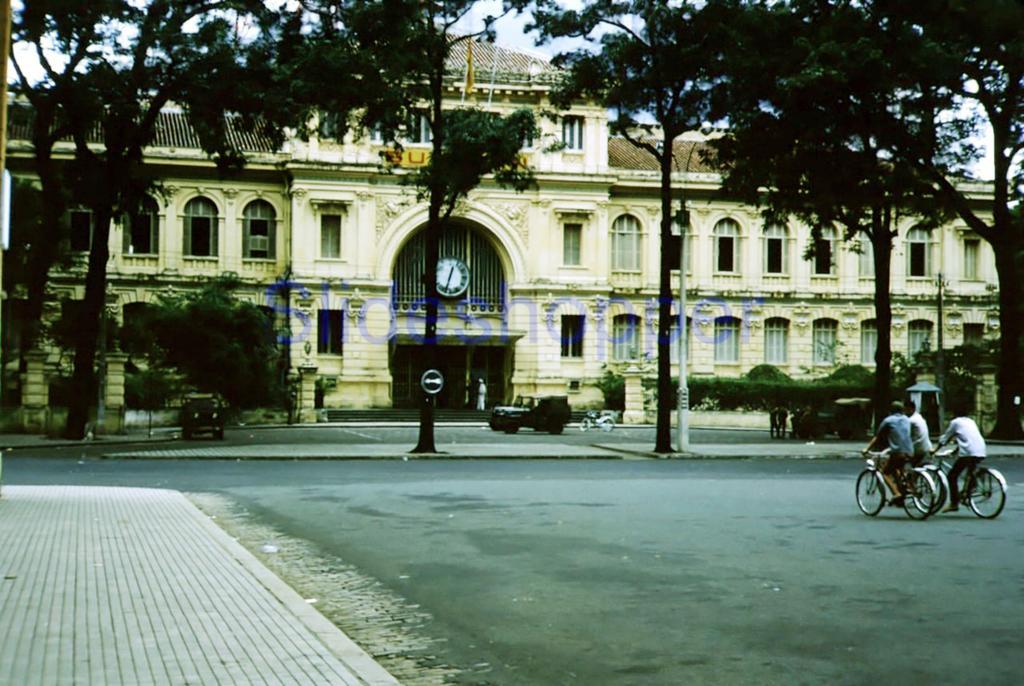Please provide a concise description of this image. There are people riding bicycles on the road. In the background we can see boards, poles, vehicles, people, trees, building, clock, plants and sky. 